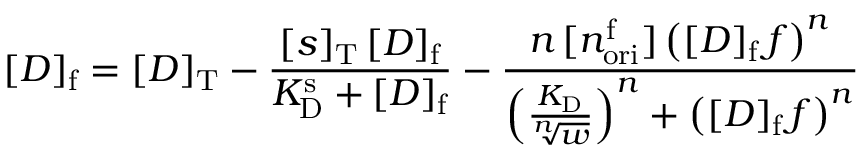<formula> <loc_0><loc_0><loc_500><loc_500>[ D ] _ { f } = [ D ] _ { T } - \frac { [ s ] _ { T } \, [ D ] _ { f } } { K _ { D } ^ { s } + [ D ] _ { f } } - \frac { n \, [ n _ { o r i } ^ { f } ] \left ( [ D ] _ { f } \, f \right ) ^ { n } } { \left ( \frac { K _ { D } } { \sqrt { [ } n ] { w } } \right ) ^ { n } + \left ( [ D ] _ { f } \, f \right ) ^ { n } }</formula> 